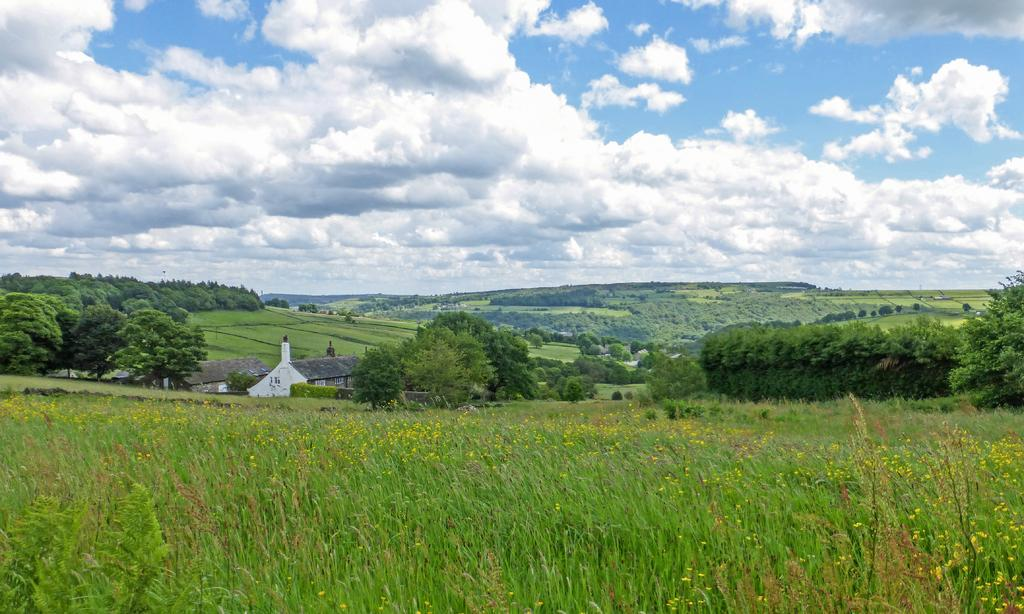What type of structures can be seen in the image? There are houses in the image. What kind of vegetation is present in the image? There are plants with flowers in the image. What can be seen in the background of the image? There are trees and grass in the background of the image. How would you describe the sky in the image? The sky is cloudy in the background of the image. What type of meal is being prepared in the image? There is no indication of a meal being prepared in the image. Can you see a bear in the image? No, there is no bear present in the image. 